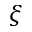<formula> <loc_0><loc_0><loc_500><loc_500>\xi</formula> 